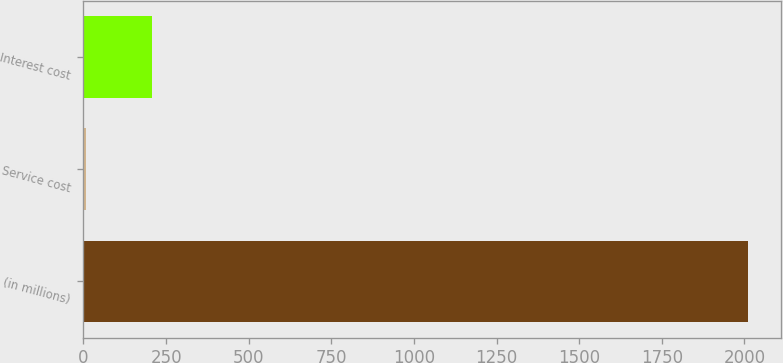Convert chart to OTSL. <chart><loc_0><loc_0><loc_500><loc_500><bar_chart><fcel>(in millions)<fcel>Service cost<fcel>Interest cost<nl><fcel>2010<fcel>8<fcel>208.2<nl></chart> 